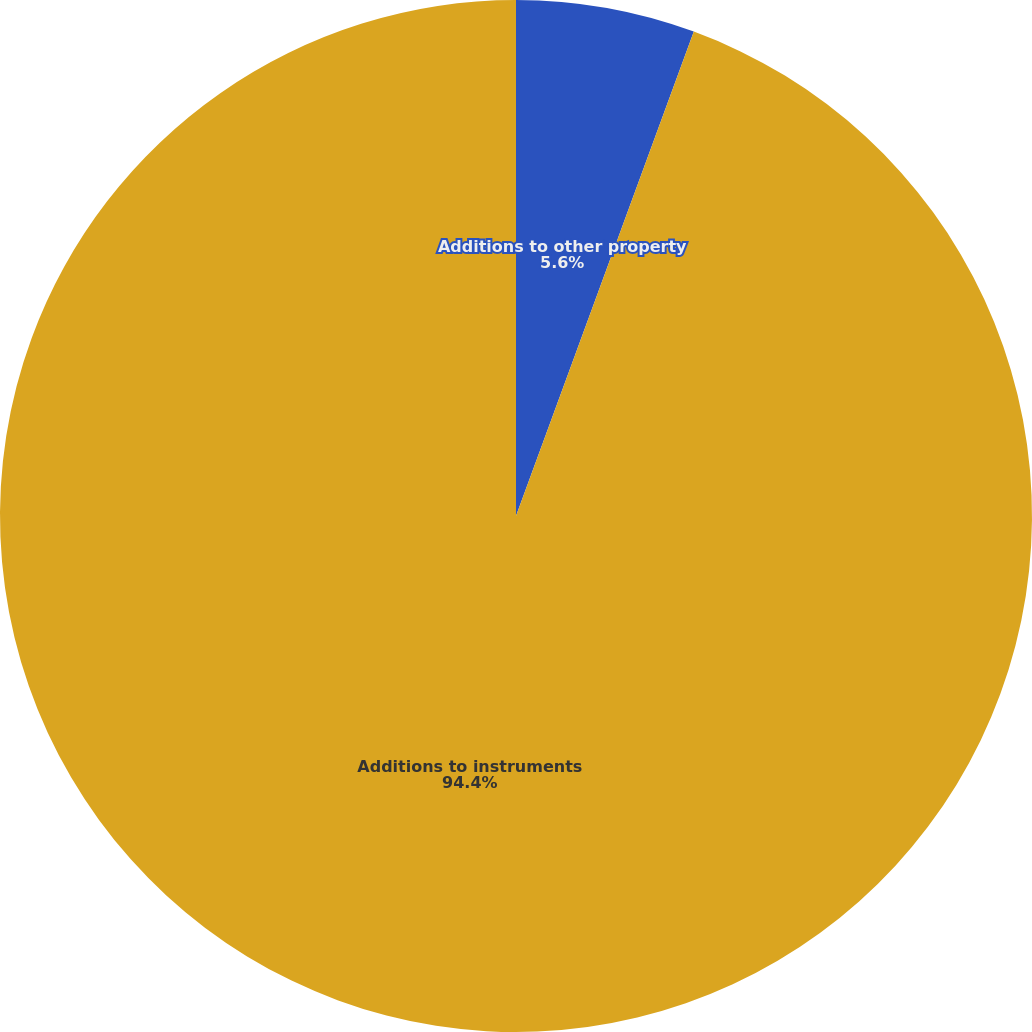<chart> <loc_0><loc_0><loc_500><loc_500><pie_chart><fcel>Additions to other property<fcel>Additions to instruments<nl><fcel>5.6%<fcel>94.4%<nl></chart> 